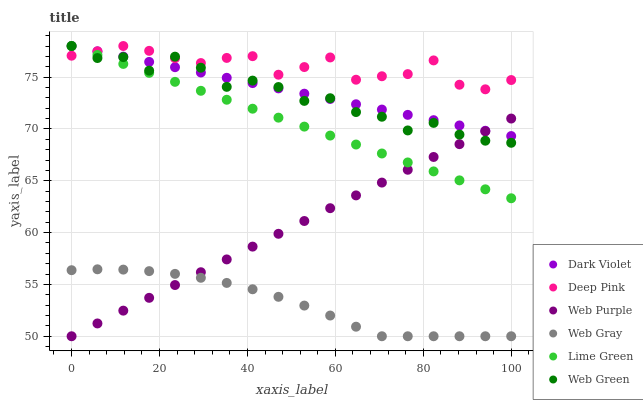Does Web Gray have the minimum area under the curve?
Answer yes or no. Yes. Does Deep Pink have the maximum area under the curve?
Answer yes or no. Yes. Does Web Green have the minimum area under the curve?
Answer yes or no. No. Does Web Green have the maximum area under the curve?
Answer yes or no. No. Is Lime Green the smoothest?
Answer yes or no. Yes. Is Web Green the roughest?
Answer yes or no. Yes. Is Web Purple the smoothest?
Answer yes or no. No. Is Web Purple the roughest?
Answer yes or no. No. Does Web Purple have the lowest value?
Answer yes or no. Yes. Does Web Green have the lowest value?
Answer yes or no. No. Does Lime Green have the highest value?
Answer yes or no. Yes. Does Web Purple have the highest value?
Answer yes or no. No. Is Web Gray less than Lime Green?
Answer yes or no. Yes. Is Dark Violet greater than Web Gray?
Answer yes or no. Yes. Does Web Purple intersect Lime Green?
Answer yes or no. Yes. Is Web Purple less than Lime Green?
Answer yes or no. No. Is Web Purple greater than Lime Green?
Answer yes or no. No. Does Web Gray intersect Lime Green?
Answer yes or no. No. 